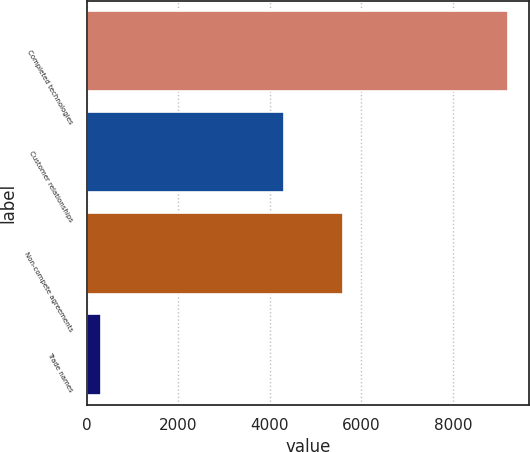Convert chart to OTSL. <chart><loc_0><loc_0><loc_500><loc_500><bar_chart><fcel>Completed technologies<fcel>Customer relationships<fcel>Non-compete agreements<fcel>Trade names<nl><fcel>9200<fcel>4300<fcel>5600<fcel>300<nl></chart> 